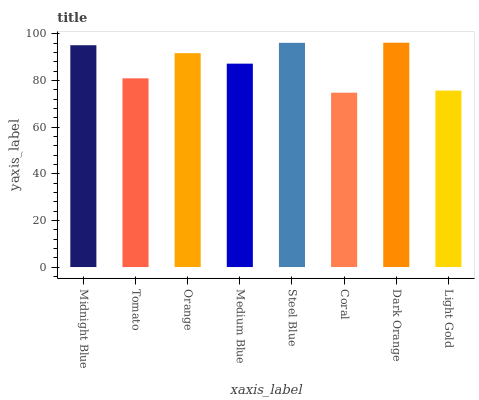Is Coral the minimum?
Answer yes or no. Yes. Is Dark Orange the maximum?
Answer yes or no. Yes. Is Tomato the minimum?
Answer yes or no. No. Is Tomato the maximum?
Answer yes or no. No. Is Midnight Blue greater than Tomato?
Answer yes or no. Yes. Is Tomato less than Midnight Blue?
Answer yes or no. Yes. Is Tomato greater than Midnight Blue?
Answer yes or no. No. Is Midnight Blue less than Tomato?
Answer yes or no. No. Is Orange the high median?
Answer yes or no. Yes. Is Medium Blue the low median?
Answer yes or no. Yes. Is Dark Orange the high median?
Answer yes or no. No. Is Coral the low median?
Answer yes or no. No. 